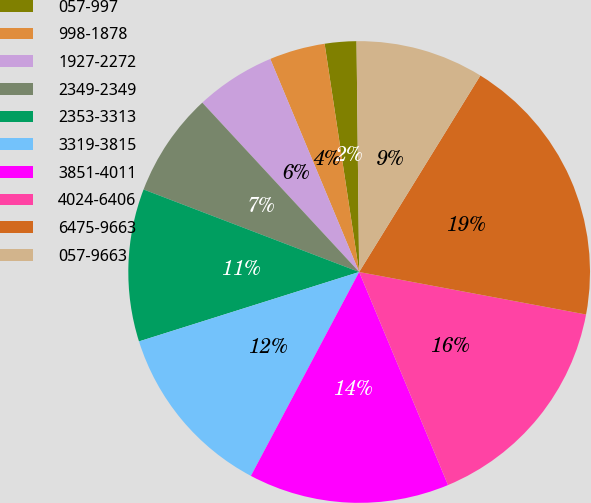Convert chart to OTSL. <chart><loc_0><loc_0><loc_500><loc_500><pie_chart><fcel>057-997<fcel>998-1878<fcel>1927-2272<fcel>2349-2349<fcel>2353-3313<fcel>3319-3815<fcel>3851-4011<fcel>4024-6406<fcel>6475-9663<fcel>057-9663<nl><fcel>2.21%<fcel>3.9%<fcel>5.6%<fcel>7.29%<fcel>10.68%<fcel>12.37%<fcel>14.06%<fcel>15.76%<fcel>19.15%<fcel>8.98%<nl></chart> 